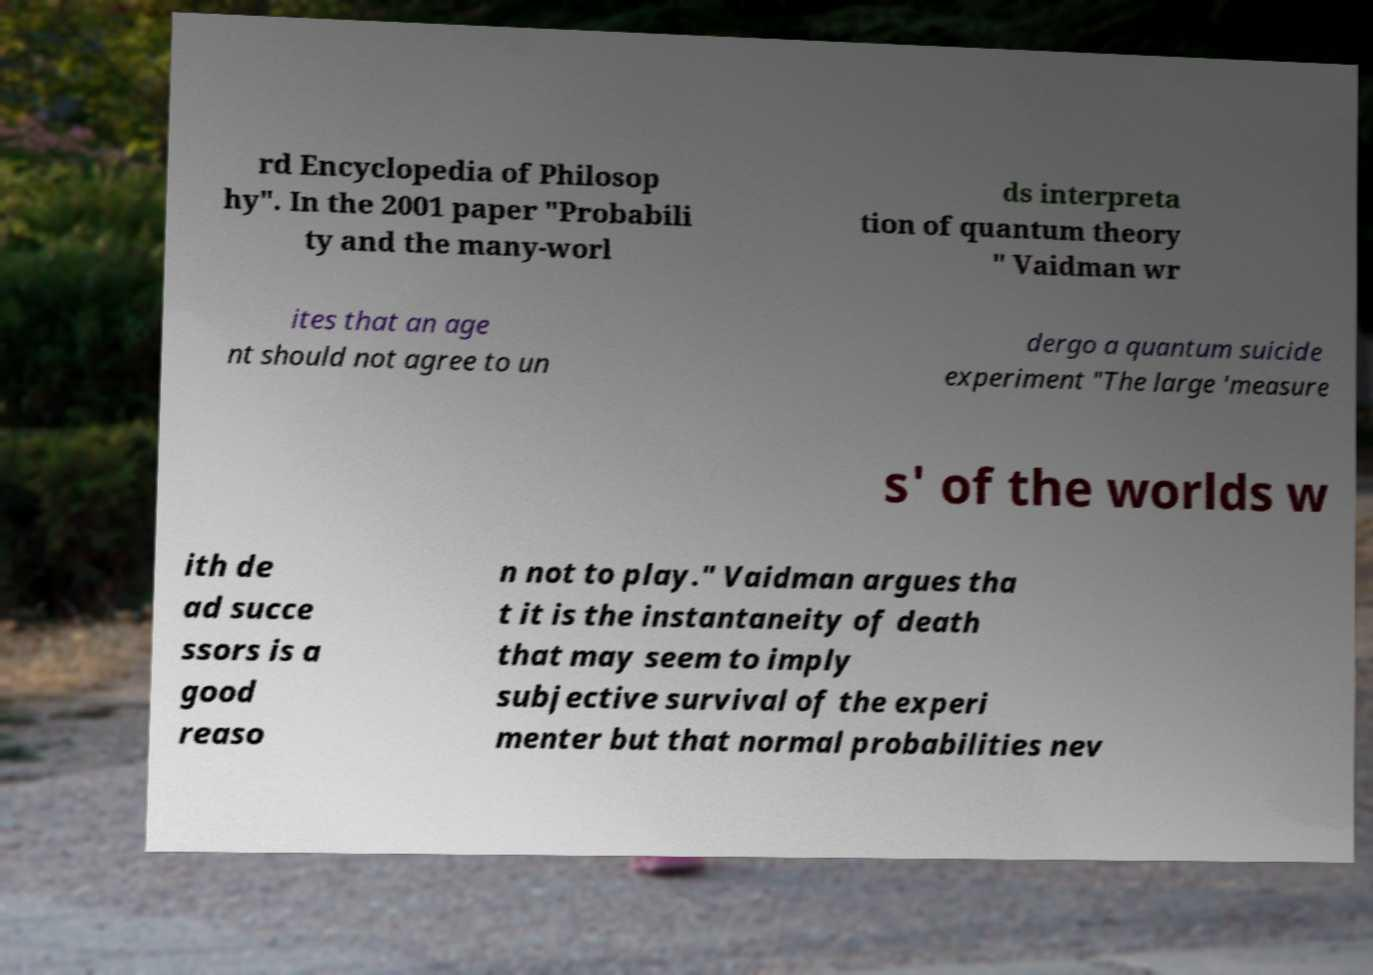Please identify and transcribe the text found in this image. rd Encyclopedia of Philosop hy". In the 2001 paper "Probabili ty and the many-worl ds interpreta tion of quantum theory " Vaidman wr ites that an age nt should not agree to un dergo a quantum suicide experiment "The large 'measure s' of the worlds w ith de ad succe ssors is a good reaso n not to play." Vaidman argues tha t it is the instantaneity of death that may seem to imply subjective survival of the experi menter but that normal probabilities nev 